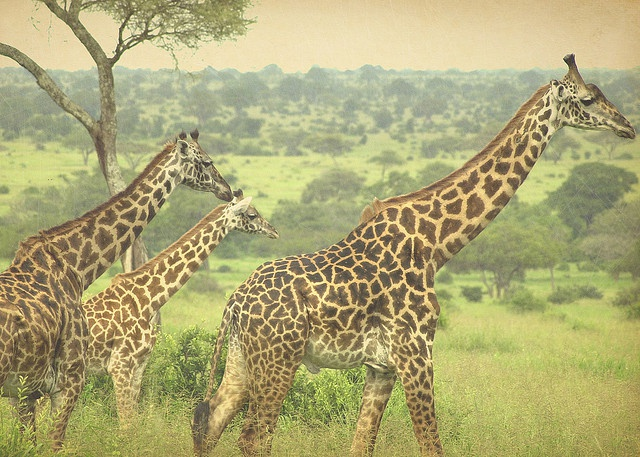Describe the objects in this image and their specific colors. I can see giraffe in tan, gray, and khaki tones, giraffe in tan and gray tones, and giraffe in tan, khaki, and olive tones in this image. 